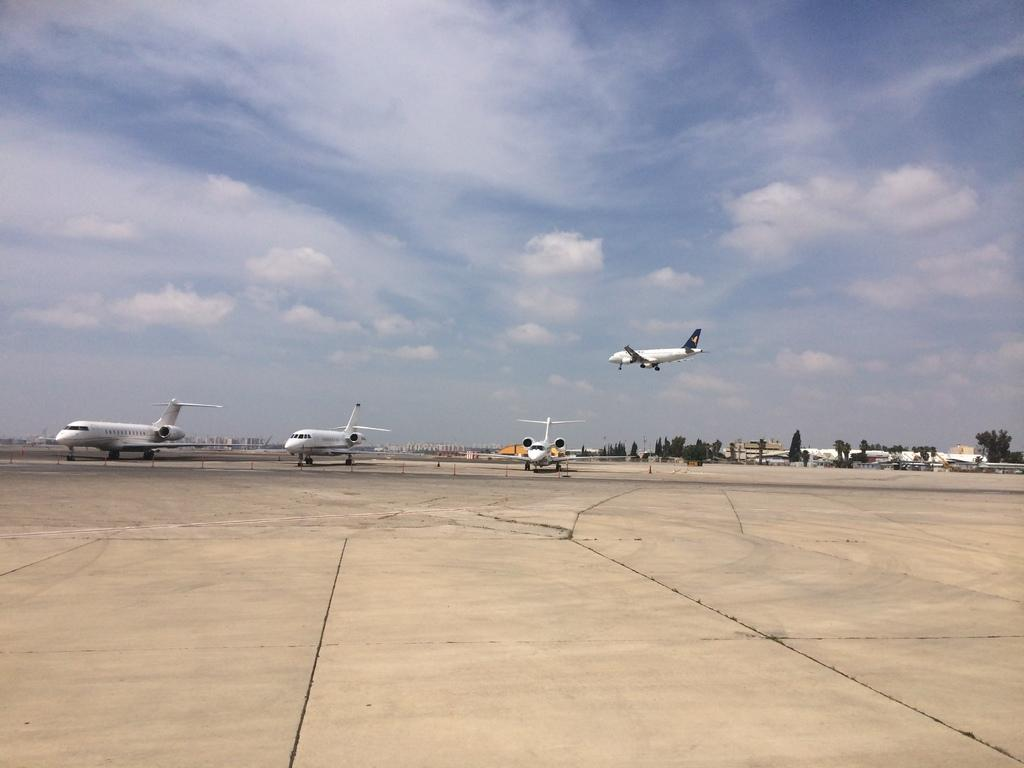What is located in the middle of the image? There are planes in the middle of the image. What can be seen behind the planes? There are trees behind the planes. What is visible at the top of the image? The sky and clouds are visible at the top of the image. What level of connection can be seen between the geese and the planes in the image? There are no geese present in the image, so it is not possible to determine the level of connection between them and the planes. 